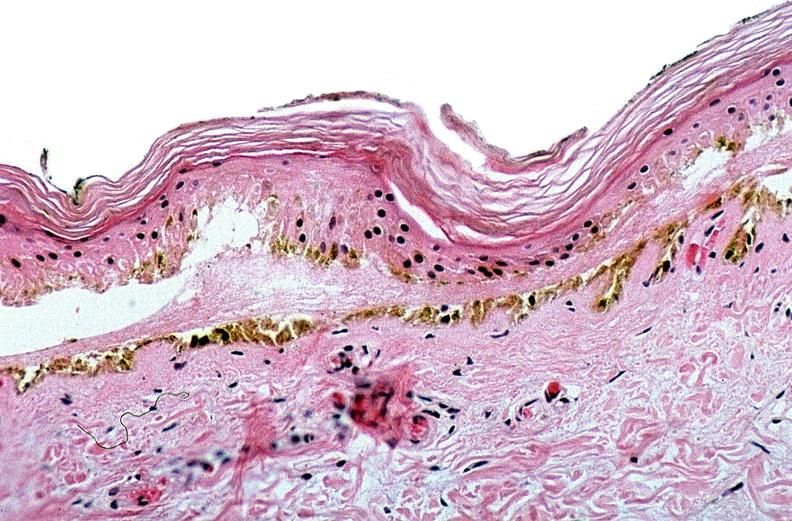does immunoperoxidate show thermal burned skin?
Answer the question using a single word or phrase. No 